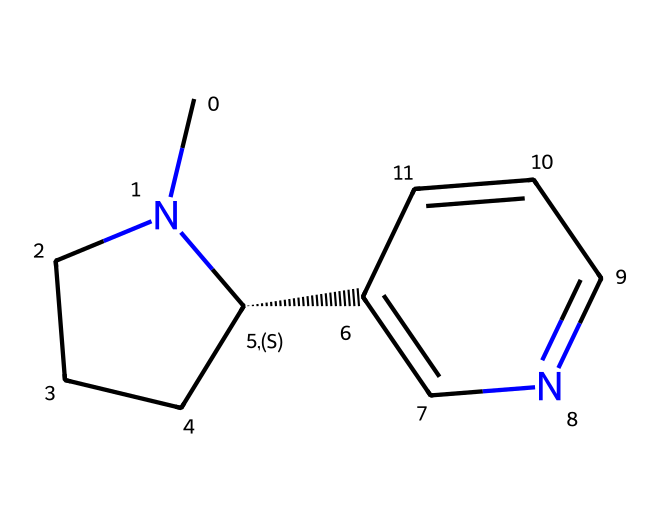What is the molecular formula of this chemical? To determine the molecular formula from the given SMILES, we count the elements present. The SMILES shows carbon (C), hydrogen (H), and nitrogen (N). Counting these gives us: 10 carbon atoms, 12 hydrogen atoms, and 2 nitrogen atoms. Therefore, the molecular formula is C10H12N2.
Answer: C10H12N2 How many rings are present in this structure? From the SMILES, we identify numbers that indicate ring formation. There are two instances of "1" and "2" in the SMILES, suggesting that there are two distinct cycles in the structure. Thus, there are two rings present.
Answer: 2 What type of compound is nicotine classified as? Nicotine contains nitrogen atoms and has a specific structure relevant to its action within the body, characterizing it as an alkaloid. Alkaloids are organic compounds that mostly contain basic nitrogen atoms and are known for their pharmacological effects.
Answer: alkaloid How many nitrogen atoms are in this molecule? By examining the SMILES, we can see that the nitrogen atoms are denoted by 'N' and count them. There are two distinct nitrogen atoms in the structure indicated by the two 'N's present.
Answer: 2 What is the primary functional group present in nicotine? Looking at the structure, nicotine contains a pyridine and a piperidine component, but the primary functional group that is characteristic of nicotine is the pyridine ring due to the nitrogen atoms contributing to its cyclic structure.
Answer: pyridine Is nicotine a saturated or unsaturated compound? Analyzing the presence of double bonds within the rings represented in the SMILES, we can see unsaturation due to the carbon-carbon double bonds present in the structure. As a result, nicotine is classified as an unsaturated compound.
Answer: unsaturated 